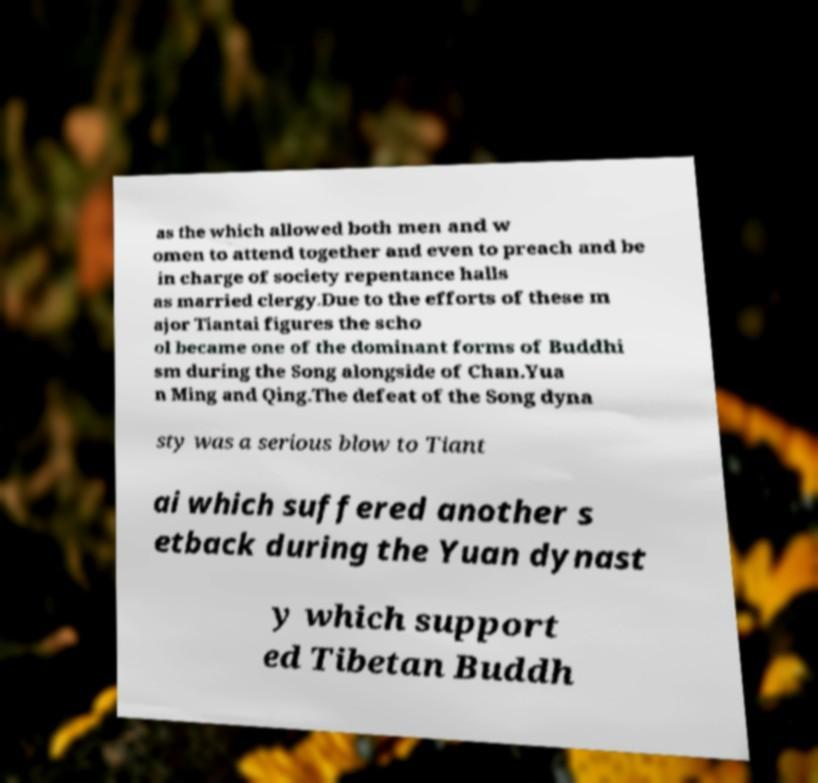Can you read and provide the text displayed in the image?This photo seems to have some interesting text. Can you extract and type it out for me? as the which allowed both men and w omen to attend together and even to preach and be in charge of society repentance halls as married clergy.Due to the efforts of these m ajor Tiantai figures the scho ol became one of the dominant forms of Buddhi sm during the Song alongside of Chan.Yua n Ming and Qing.The defeat of the Song dyna sty was a serious blow to Tiant ai which suffered another s etback during the Yuan dynast y which support ed Tibetan Buddh 